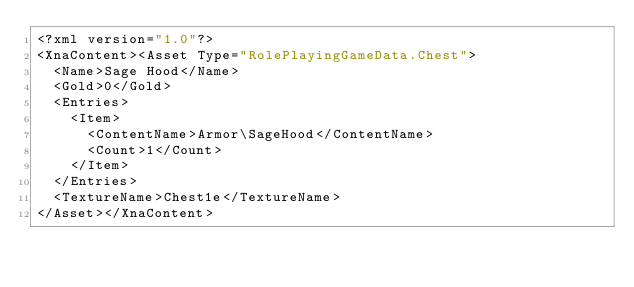<code> <loc_0><loc_0><loc_500><loc_500><_XML_><?xml version="1.0"?>
<XnaContent><Asset Type="RolePlayingGameData.Chest">
  <Name>Sage Hood</Name>
  <Gold>0</Gold>
  <Entries>
    <Item>
      <ContentName>Armor\SageHood</ContentName>
      <Count>1</Count>
    </Item>
  </Entries>
  <TextureName>Chest1e</TextureName>
</Asset></XnaContent></code> 